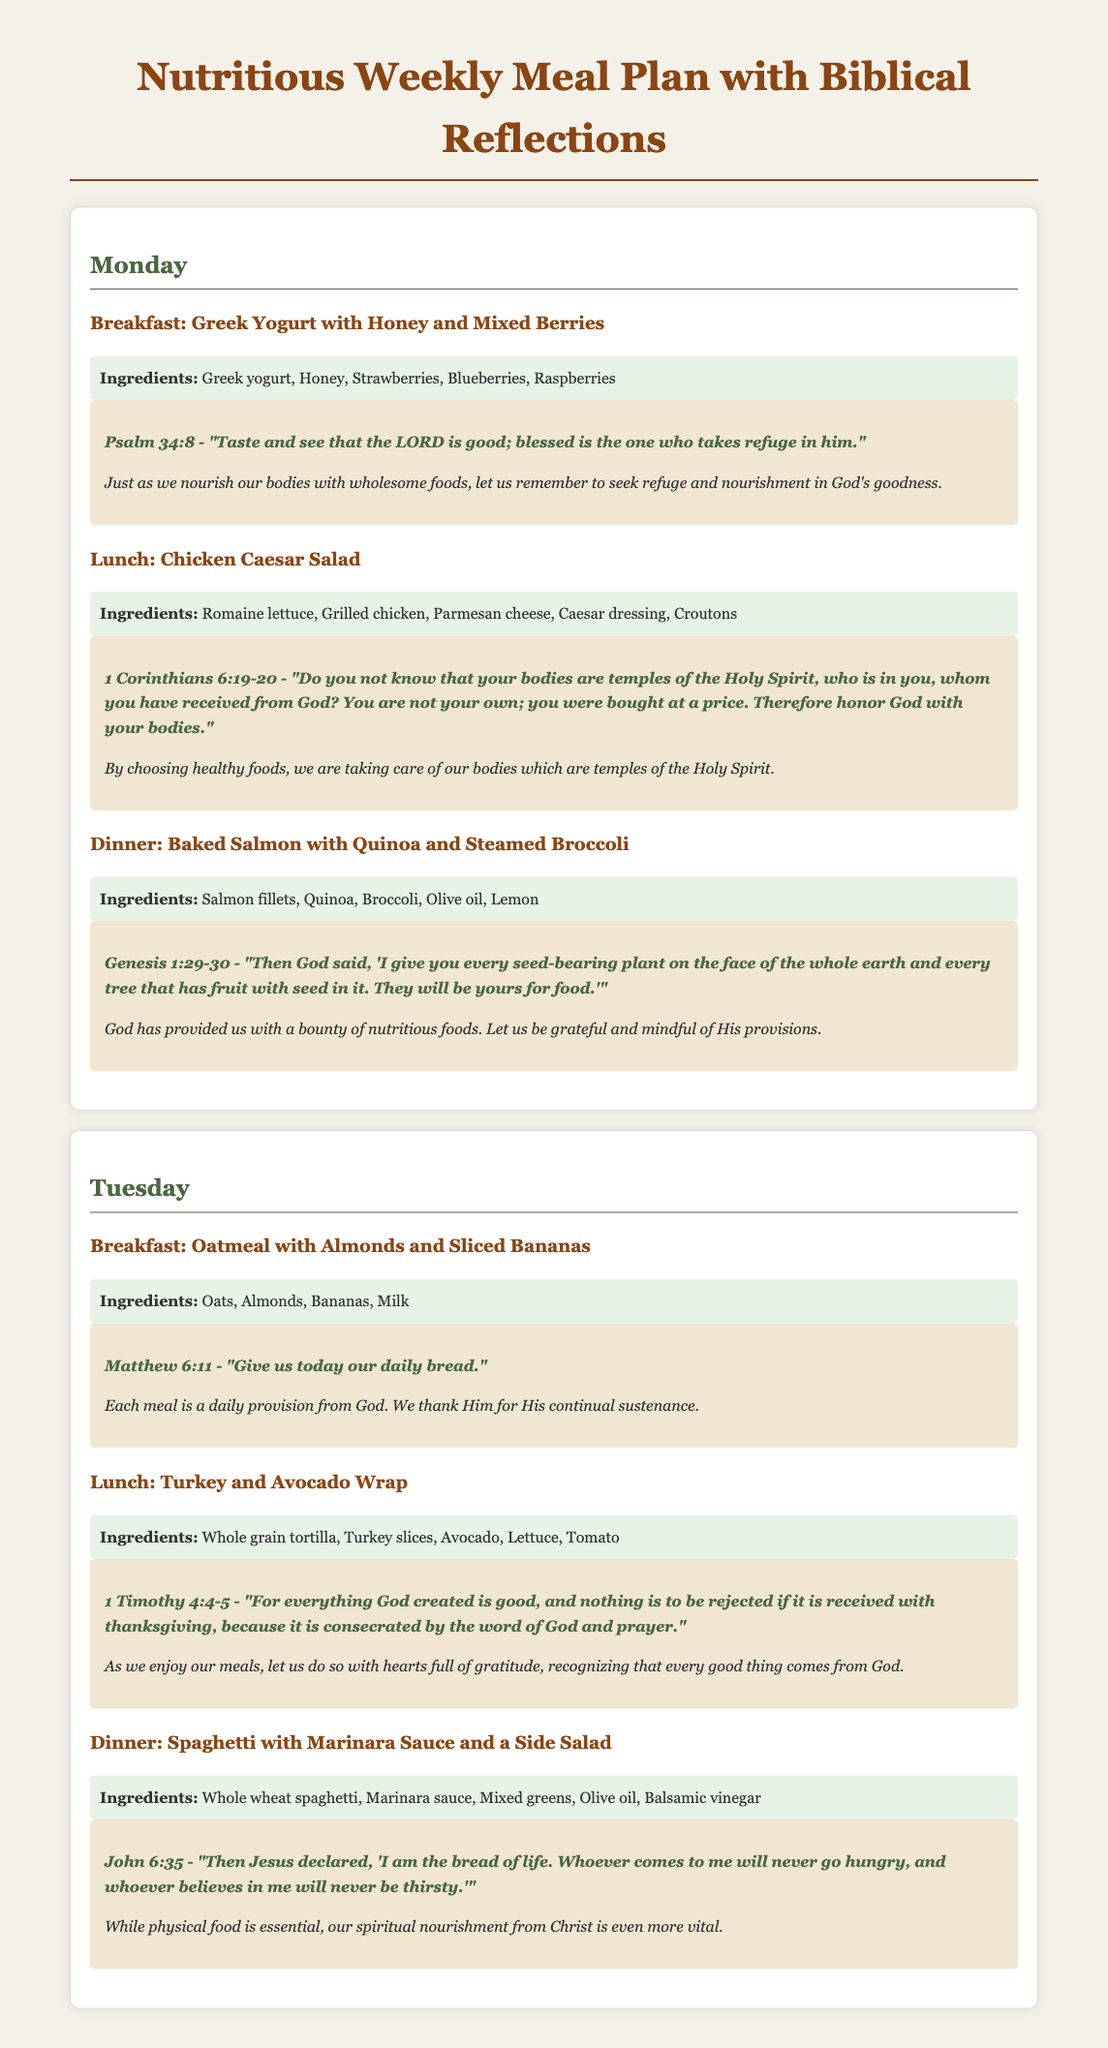What is the title of the document? The title appears at the top and states the purpose of the document clearly.
Answer: Nutritious Weekly Meal Plan with Biblical Reflections Which day is the first meal plan provided for? The meal plan begins with Monday, as indicated in the document.
Answer: Monday What is the breakfast for Tuesday? The document lists the breakfast for Tuesday under its respective section.
Answer: Oatmeal with Almonds and Sliced Bananas What verse is associated with Monday's breakfast? Each meal includes a biblical verse, and Monday's breakfast has its own.
Answer: Psalm 34:8 What is one of the ingredients in the lunch for Monday? The lunch for Monday lists several ingredients, and one can be identified.
Answer: Grilled chicken What is the main theme reflected in the biblical verses throughout the meals? The verses emphasize a common concept that relates to nourishment and gratitude for God's provisions.
Answer: Nourishment and gratitude How many meals are listed for each day? The structure of the document provides three meals for each day, allowing for easy identification.
Answer: Three Which meal includes a side salad? The dinner on Tuesday reflects the inclusion of a side dish as indicated in its description.
Answer: Spaghetti with Marinara Sauce and a Side Salad 